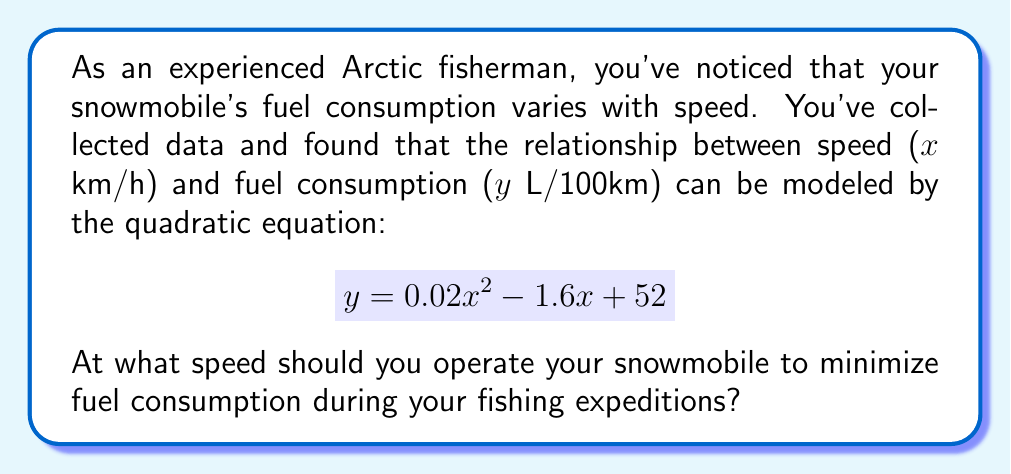Provide a solution to this math problem. To find the speed that minimizes fuel consumption, we need to find the vertex of the parabola represented by the given quadratic equation. The vertex represents the minimum point of the parabola since the coefficient of $x^2$ is positive (0.02 > 0), indicating the parabola opens upward.

For a quadratic equation in the form $y = ax^2 + bx + c$, the x-coordinate of the vertex is given by $x = -\frac{b}{2a}$.

In this case:
$a = 0.02$
$b = -1.6$
$c = 52$

Let's calculate the x-coordinate of the vertex:

$$ x = -\frac{b}{2a} = -\frac{-1.6}{2(0.02)} = \frac{1.6}{0.04} = 40 $$

Therefore, the speed that minimizes fuel consumption is 40 km/h.

To verify this, we can calculate the second derivative of the function:
$$ \frac{d^2y}{dx^2} = 2(0.02) = 0.04 > 0 $$

Since the second derivative is positive, this confirms that the vertex is indeed a minimum point.
Answer: The optimal speed to minimize fuel consumption is 40 km/h. 